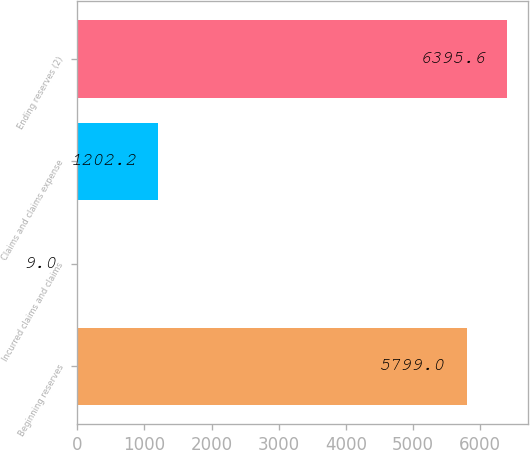<chart> <loc_0><loc_0><loc_500><loc_500><bar_chart><fcel>Beginning reserves<fcel>Incurred claims and claims<fcel>Claims and claims expense<fcel>Ending reserves (2)<nl><fcel>5799<fcel>9<fcel>1202.2<fcel>6395.6<nl></chart> 